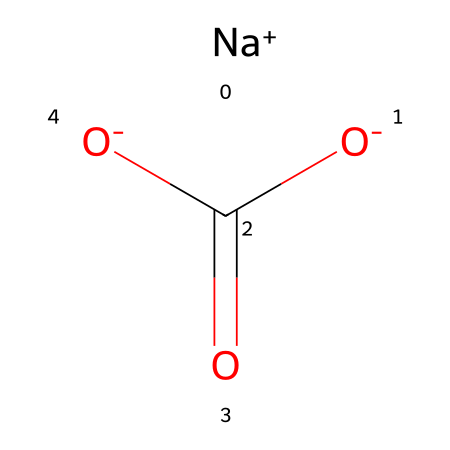How many sodium atoms are present in this chemical? The chemical structure has one sodium ion represented by [Na+], indicating that there is one sodium atom.
Answer: one What is the overall charge of this compound? The presence of one sodium ion with a +1 charge and two negatively charged carboxylate groups ([O-]C(=O)[O-]) gives the molecule an overall neutral charge, balancing out the charges.
Answer: neutral What type of chemical is sodium bicarbonate classified as? Sodium bicarbonate consists of a sodium ion and bicarbonate ion, which makes it an inorganic salt and a base due to the presence of the bicarbonate anion.
Answer: base How many oxygen atoms are in the bicarbonate functional group? In the bicarbonate ion [O-]C(=O)[O-], there are three oxygen atoms; one is part of the carbonate group (C=O) and two are negatively charged (-O).
Answer: three Which part of the chemical structure contains the acidic component? The carboxylate part represented by C(=O)[O-] indicates the acidic nature of bicarbonate, as this portion can release H+ ions.
Answer: C(=O)[O-] What is the relationship between sodium bicarbonate and carbon dioxide? When sodium bicarbonate is heated or reacts with acid, it decomposes to release carbon dioxide gas, indicating its role in effervescence.
Answer: effervescent 